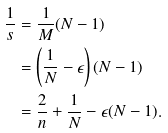Convert formula to latex. <formula><loc_0><loc_0><loc_500><loc_500>\frac { 1 } { s } & = \frac { 1 } { M } ( N - 1 ) \\ & = \left ( \frac { 1 } { N } - \epsilon \right ) ( N - 1 ) \\ & = \frac { 2 } { n } + \frac { 1 } { N } - \epsilon ( N - 1 ) .</formula> 